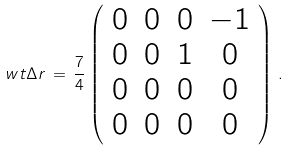<formula> <loc_0><loc_0><loc_500><loc_500>\ w t { \Delta r } \, = \, \frac { 7 } { 4 } \left ( \begin{array} { c c c c } 0 & 0 & 0 & - 1 \\ 0 & 0 & 1 & 0 \\ 0 & 0 & 0 & 0 \\ 0 & 0 & 0 & 0 \end{array} \right ) \, .</formula> 